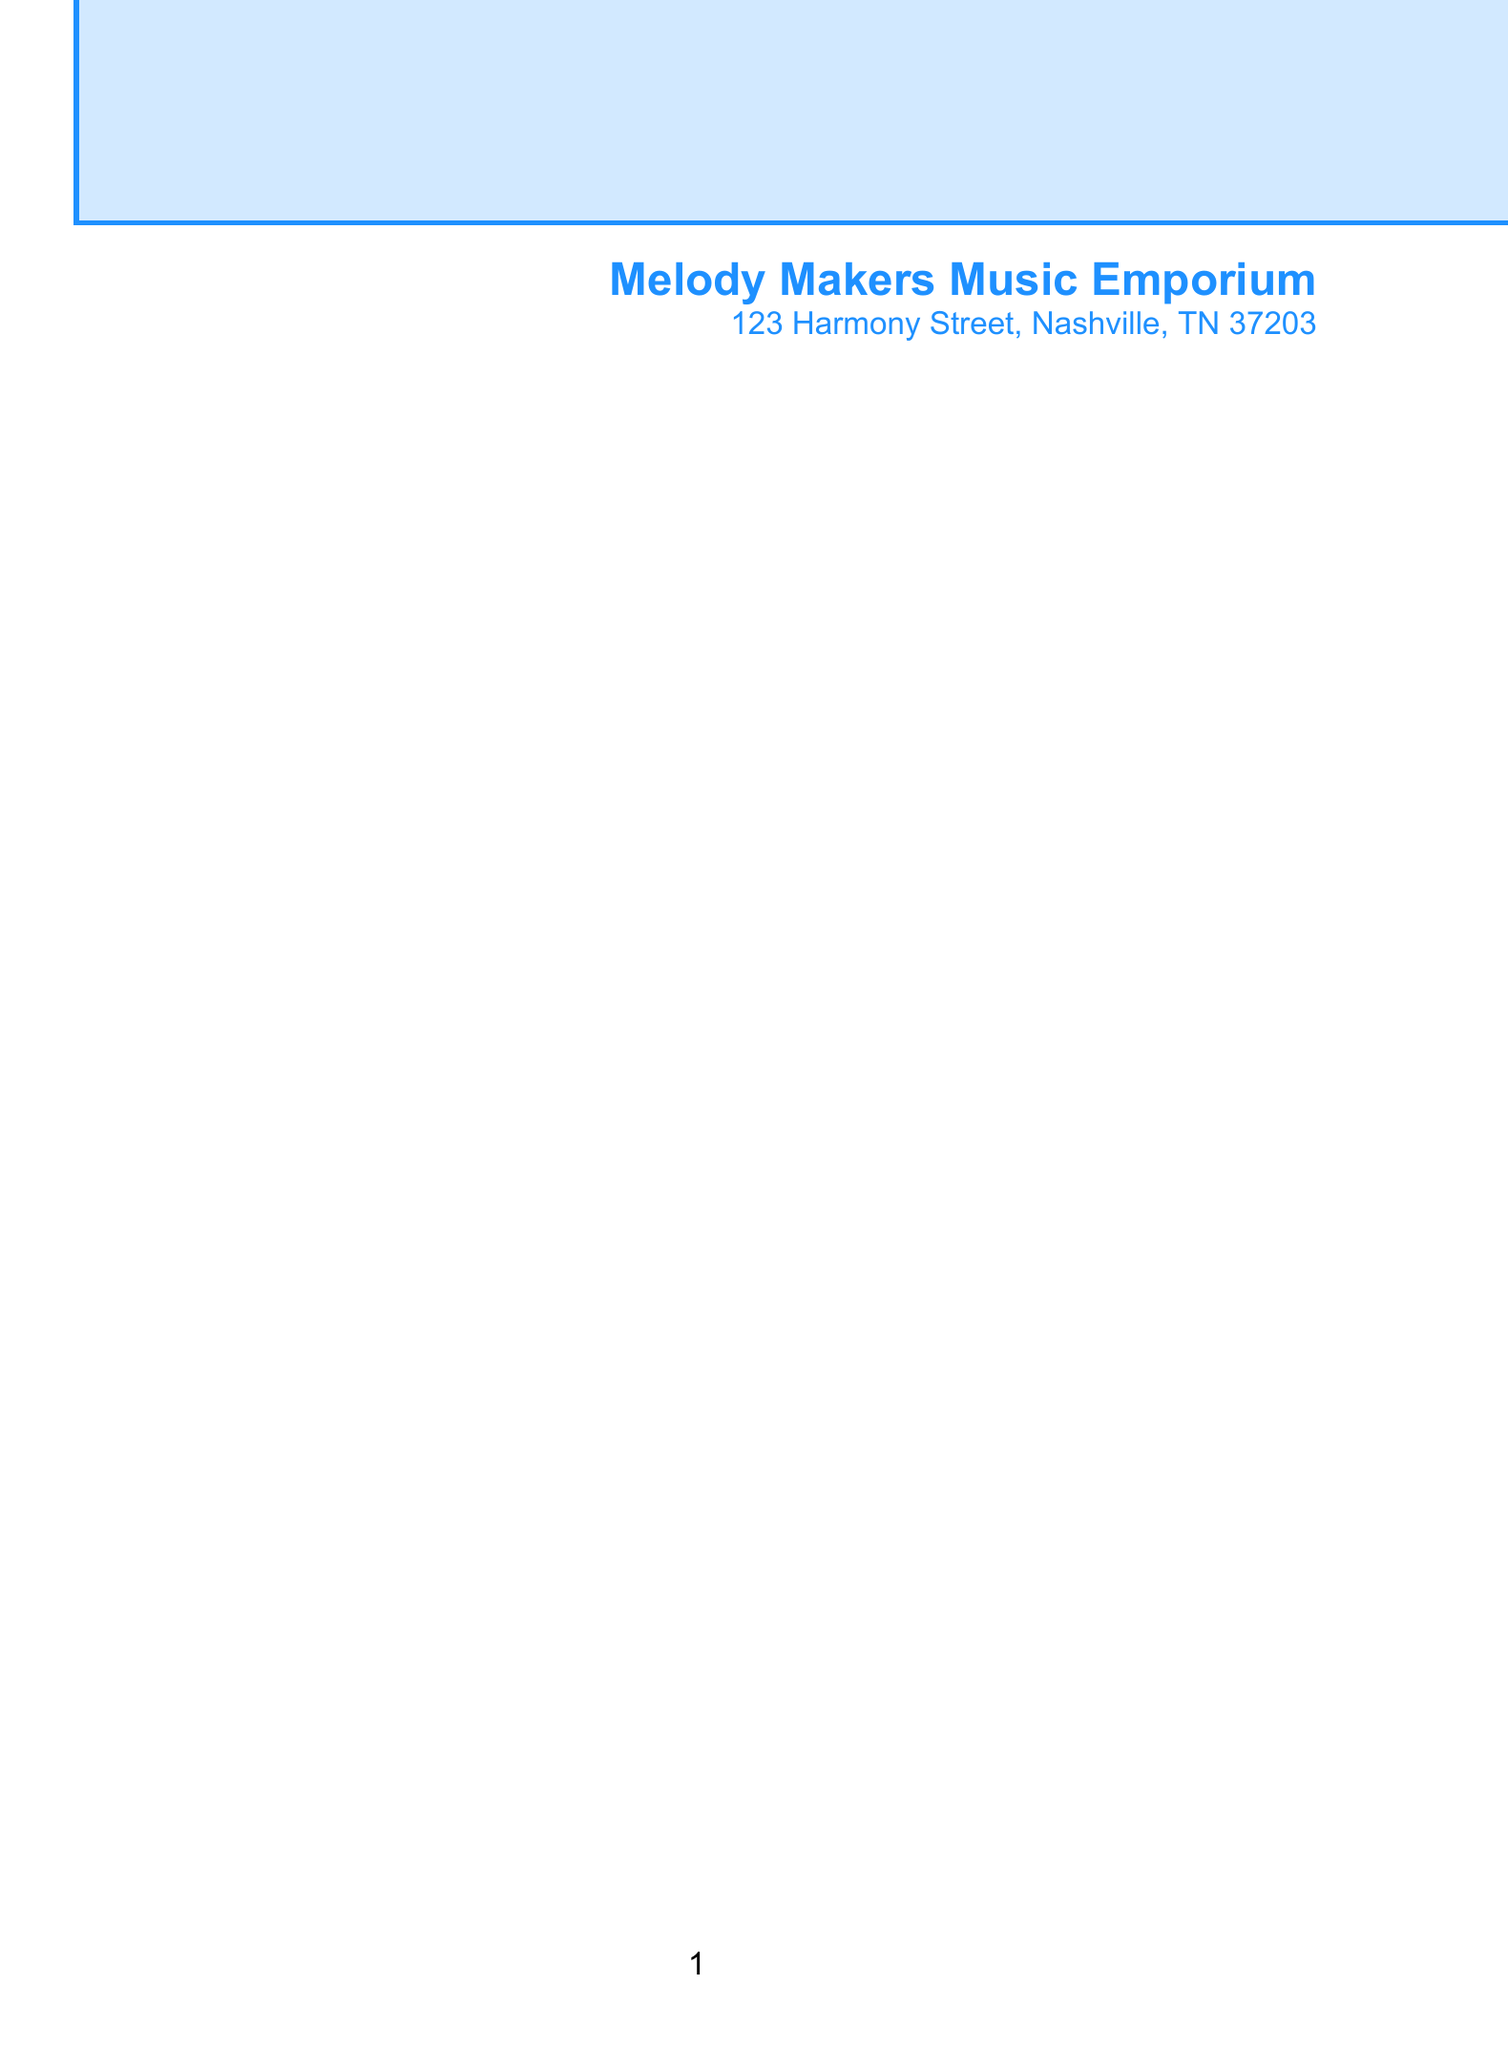what is the store's name? The store's name is provided in the letter.
Answer: Melody Makers Music Emporium who is the podcast host? The podcast host's name is mentioned at the beginning of the letter.
Answer: Alex Rodriguez what was the overall sales increase mentioned? The letter specifies the total increase in sales after the podcast episodes.
Answer: 45% which episode featured "Choosing the Right Guitar for Your Style"? The letter lists titles of episodes featured in the podcast.
Answer: Episode 42 how much did sales of the Shure SM7B Microphone increase? This is one of the products mentioned with specific sales growth in the letter.
Answer: 50% what percentage of new customers came from first-time buyers? The document states this specific percentage in the sales impact section.
Answer: 30% what is one idea for future collaboration mentioned? The letter lists potential future collaboration ideas.
Answer: Exclusive listener discounts how much increase in website traffic was reported? The letter includes a specific percentage increase in online traffic after the podcast episodes.
Answer: 75% 